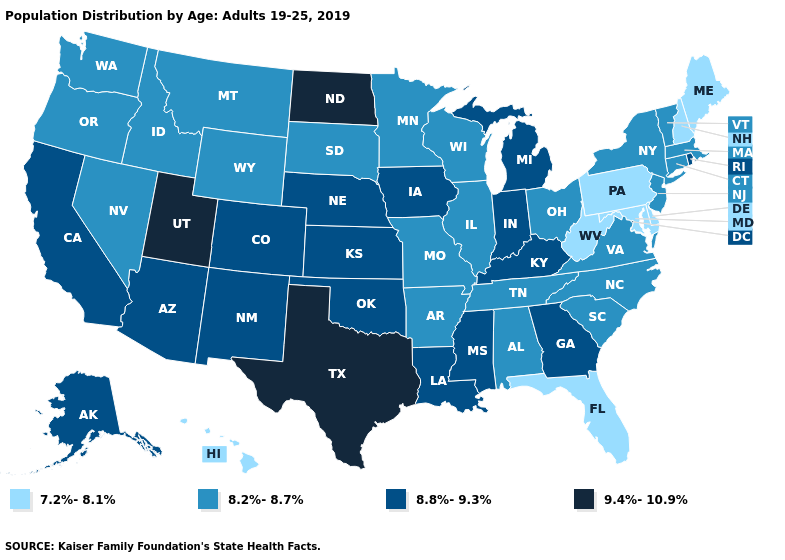Name the states that have a value in the range 7.2%-8.1%?
Short answer required. Delaware, Florida, Hawaii, Maine, Maryland, New Hampshire, Pennsylvania, West Virginia. Is the legend a continuous bar?
Keep it brief. No. Which states hav the highest value in the West?
Concise answer only. Utah. Name the states that have a value in the range 9.4%-10.9%?
Be succinct. North Dakota, Texas, Utah. Which states have the lowest value in the MidWest?
Give a very brief answer. Illinois, Minnesota, Missouri, Ohio, South Dakota, Wisconsin. What is the value of Texas?
Give a very brief answer. 9.4%-10.9%. What is the lowest value in the Northeast?
Give a very brief answer. 7.2%-8.1%. Which states have the lowest value in the South?
Write a very short answer. Delaware, Florida, Maryland, West Virginia. Among the states that border Virginia , which have the lowest value?
Concise answer only. Maryland, West Virginia. What is the value of Delaware?
Be succinct. 7.2%-8.1%. What is the lowest value in states that border Minnesota?
Short answer required. 8.2%-8.7%. What is the value of North Carolina?
Keep it brief. 8.2%-8.7%. Among the states that border Idaho , which have the lowest value?
Be succinct. Montana, Nevada, Oregon, Washington, Wyoming. What is the value of California?
Short answer required. 8.8%-9.3%. Does the map have missing data?
Answer briefly. No. 